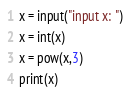Convert code to text. <code><loc_0><loc_0><loc_500><loc_500><_Python_>x = input("input x: ")
x = int(x)
x = pow(x,3)
print(x)</code> 